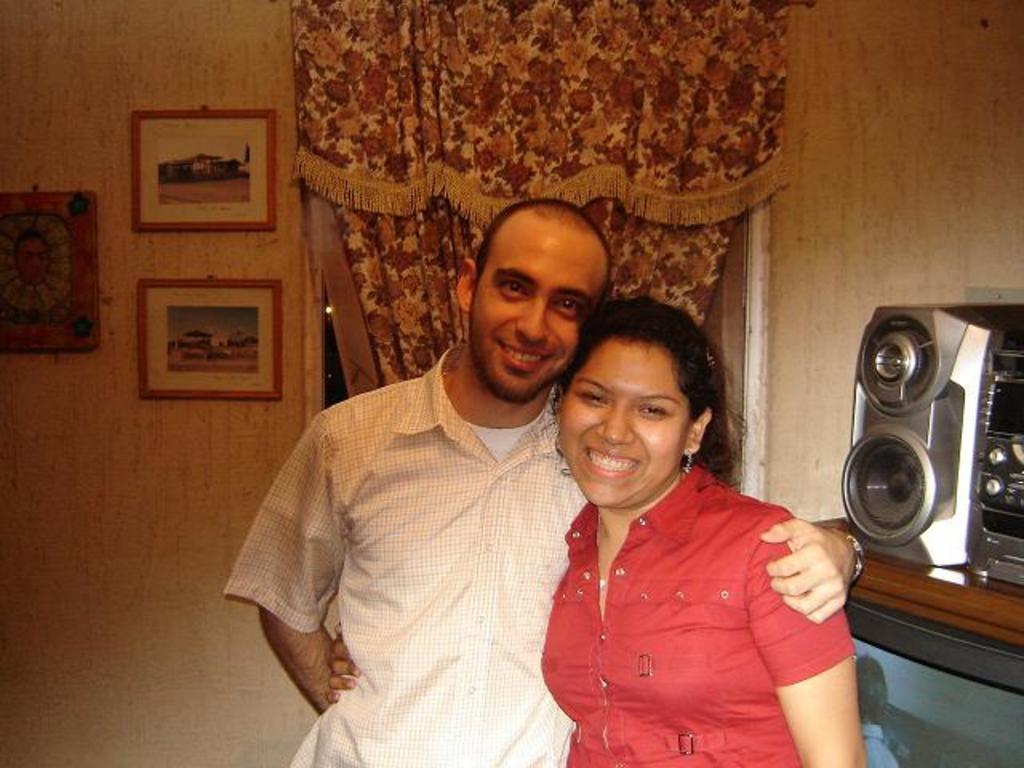In one or two sentences, can you explain what this image depicts? In this image, we can see a woman and man are watching and smiling. They are standing side by side holding with each other. Background there is a wall, photo frames, curtain. Right side of the image, we can see the speaker, music player and television with screen 